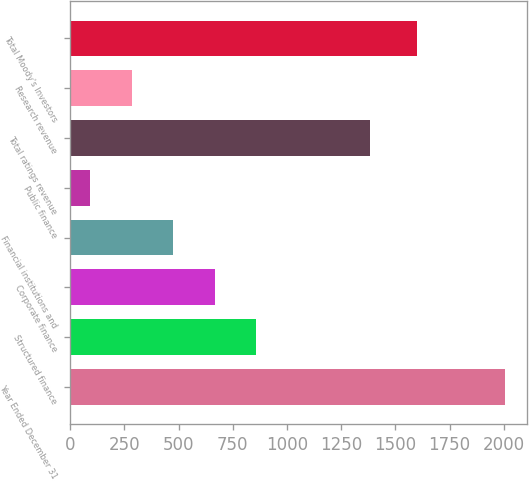<chart> <loc_0><loc_0><loc_500><loc_500><bar_chart><fcel>Year Ended December 31<fcel>Structured finance<fcel>Corporate finance<fcel>Financial institutions and<fcel>Public finance<fcel>Total ratings revenue<fcel>Research revenue<fcel>Total Moody's Investors<nl><fcel>2005<fcel>857.08<fcel>665.76<fcel>474.44<fcel>91.8<fcel>1383.6<fcel>283.12<fcel>1598.9<nl></chart> 